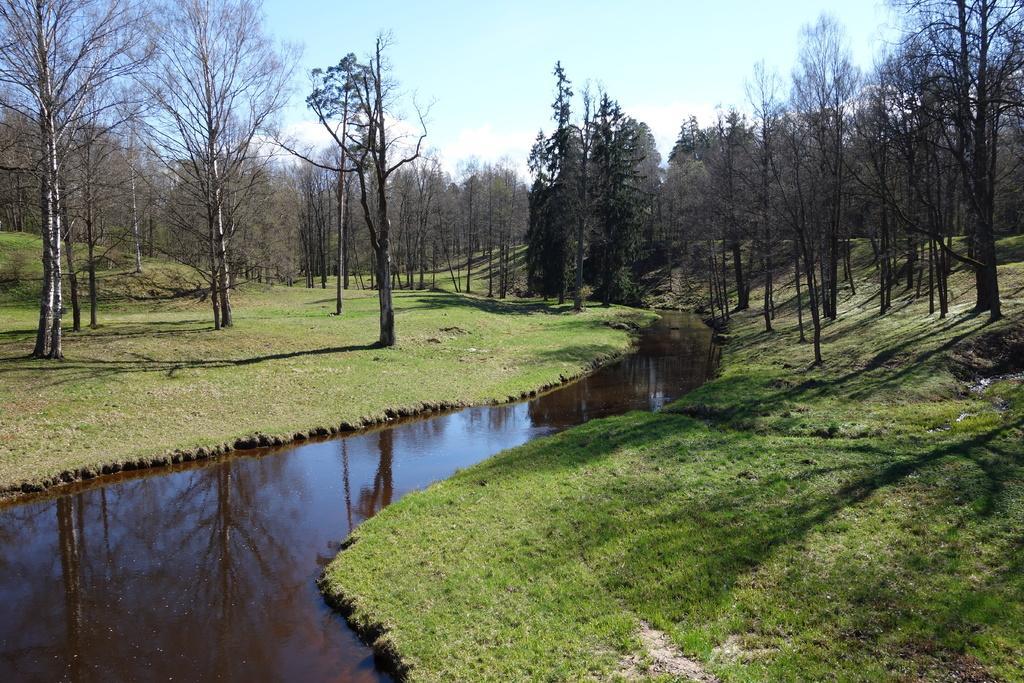Could you give a brief overview of what you see in this image? In this picture we can see many trees. On the bottom we can see water and grass. At the top we can see sky and clouds. 